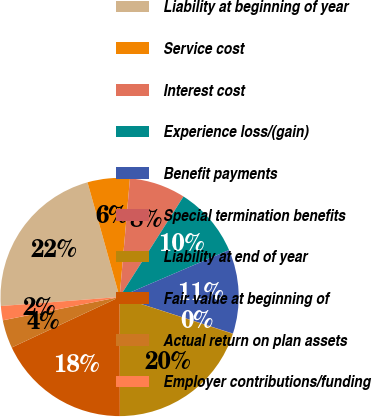<chart> <loc_0><loc_0><loc_500><loc_500><pie_chart><fcel>Liability at beginning of year<fcel>Service cost<fcel>Interest cost<fcel>Experience loss/(gain)<fcel>Benefit payments<fcel>Special termination benefits<fcel>Liability at end of year<fcel>Fair value at beginning of<fcel>Actual return on plan assets<fcel>Employer contributions/funding<nl><fcel>21.87%<fcel>5.73%<fcel>7.63%<fcel>9.53%<fcel>11.43%<fcel>0.03%<fcel>19.97%<fcel>18.07%<fcel>3.83%<fcel>1.93%<nl></chart> 